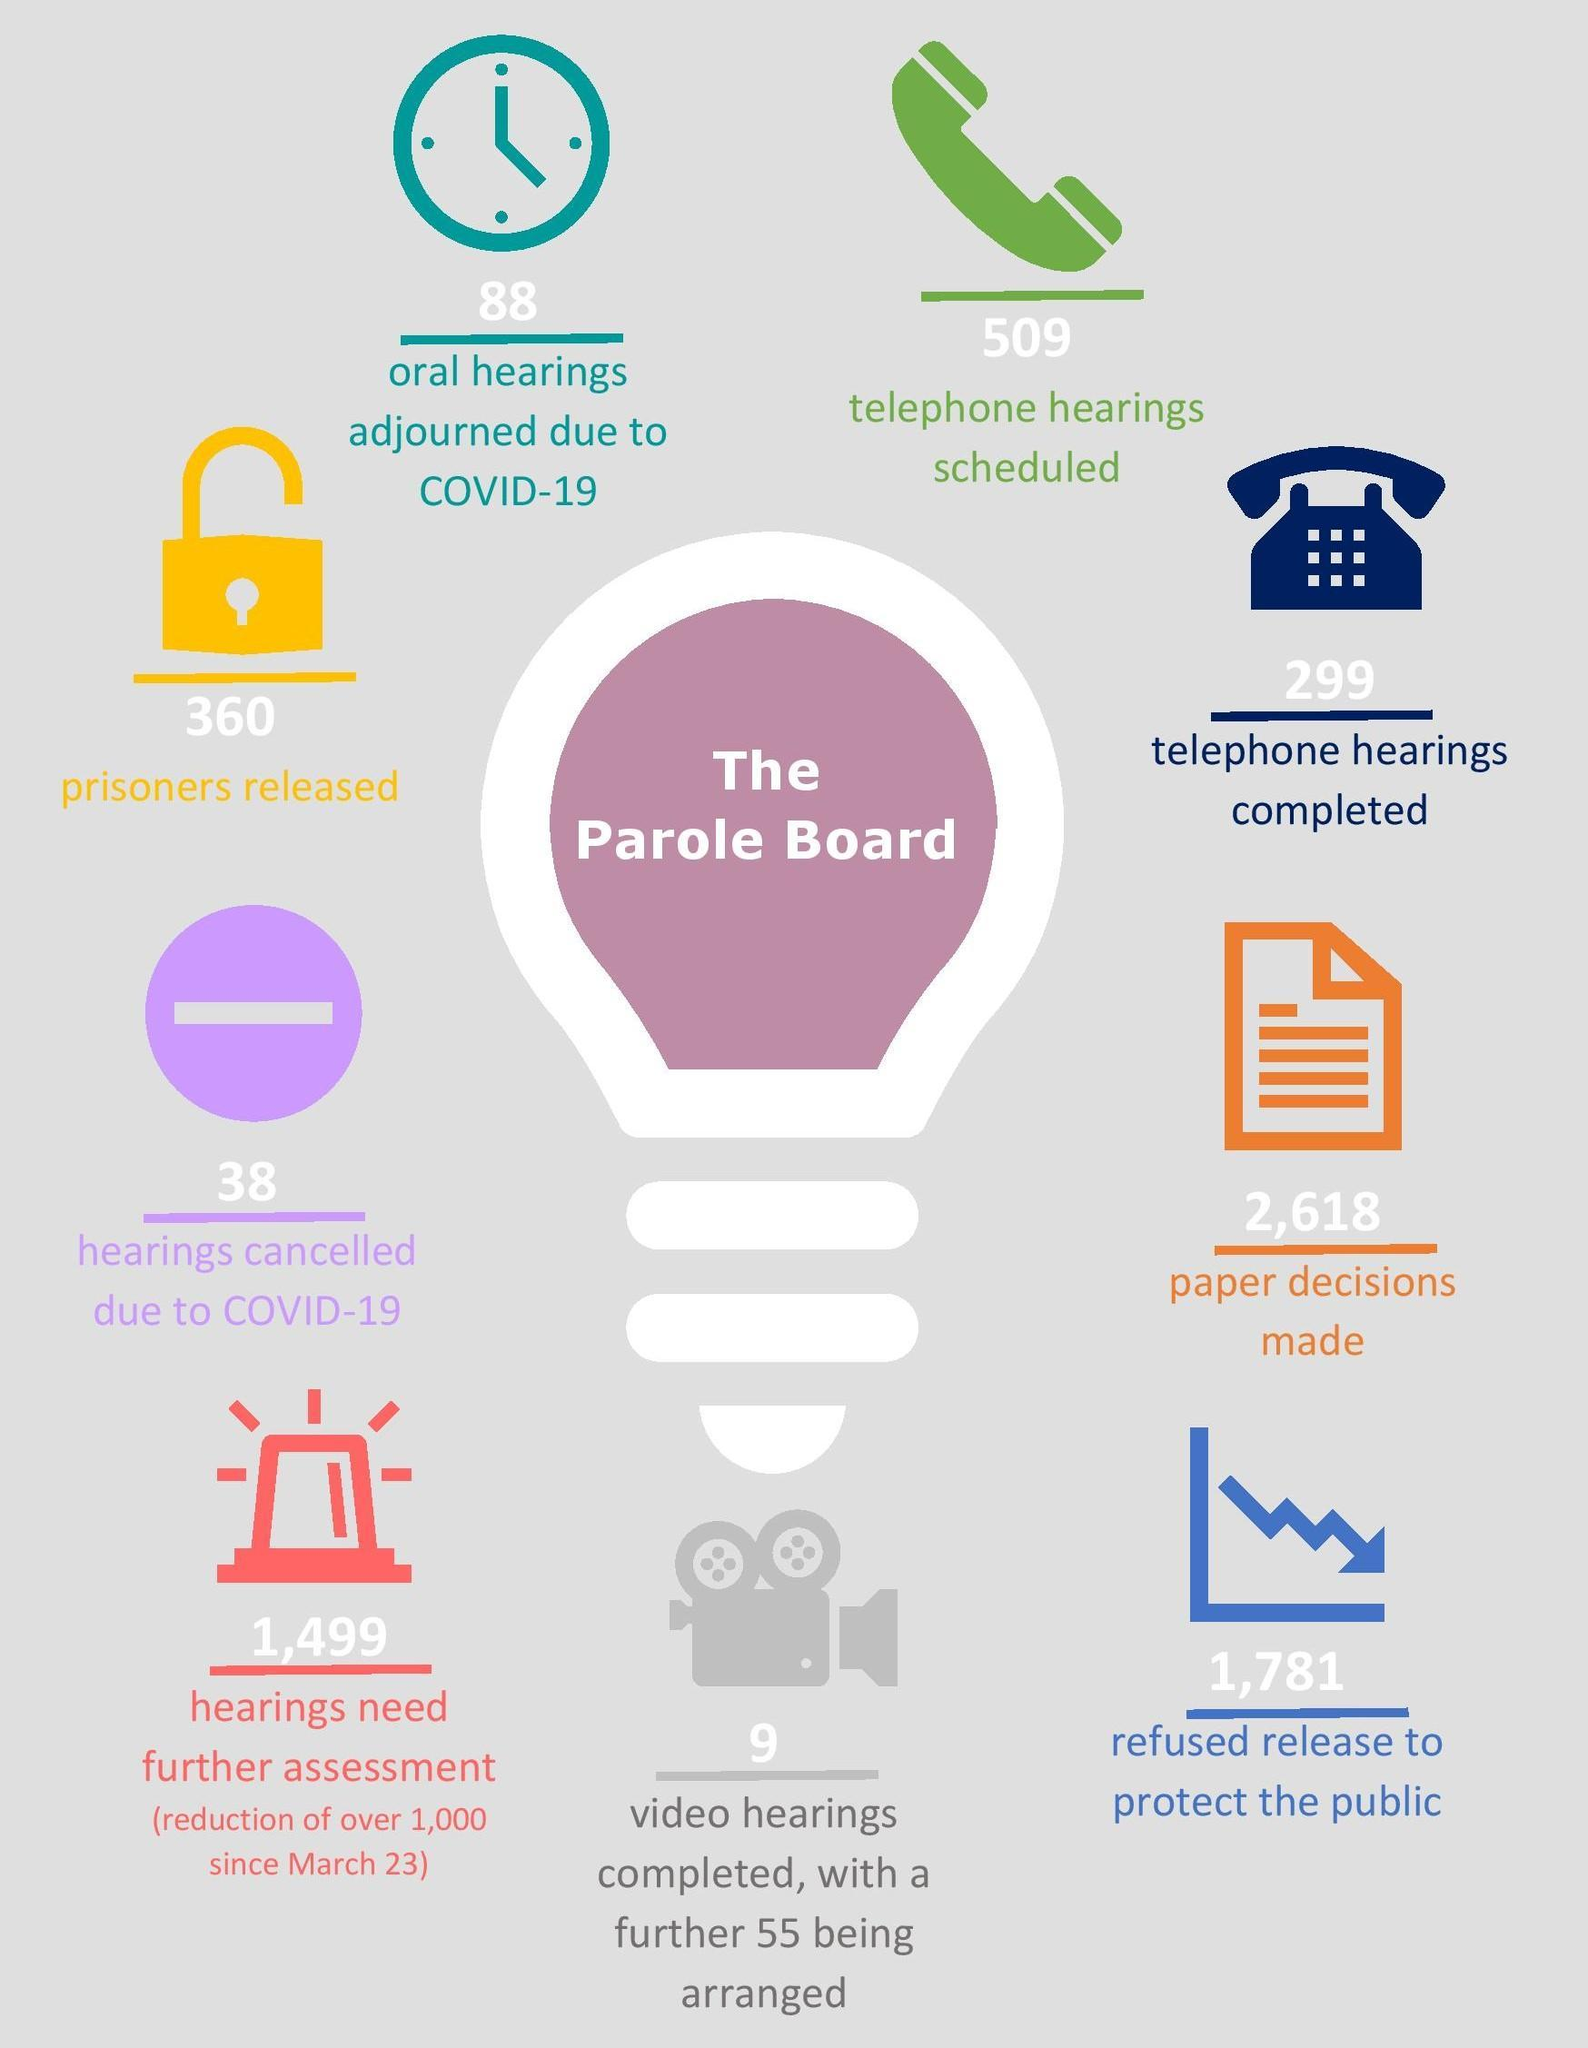how many hearings need further assessment
Answer the question with a short phrase. 1,499 What is the difference between the telephone hearings scheduled and completed 210 which departments activities are being discussed parole board what is the total count of prisoners released and hearings cancelled due to COVID-19 398 what is the colour of the lock, yellow or blue? yellow 